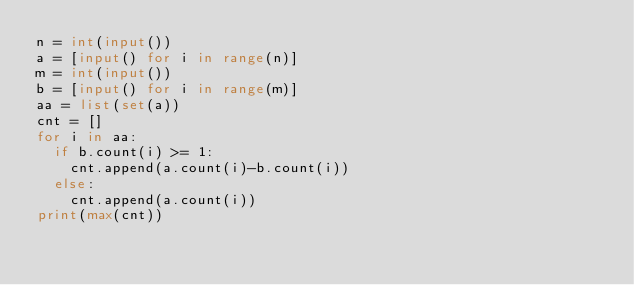Convert code to text. <code><loc_0><loc_0><loc_500><loc_500><_Python_>n = int(input())
a = [input() for i in range(n)]
m = int(input())
b = [input() for i in range(m)]
aa = list(set(a))
cnt = []
for i in aa:
  if b.count(i) >= 1:
    cnt.append(a.count(i)-b.count(i))
  else:
    cnt.append(a.count(i))
print(max(cnt))</code> 